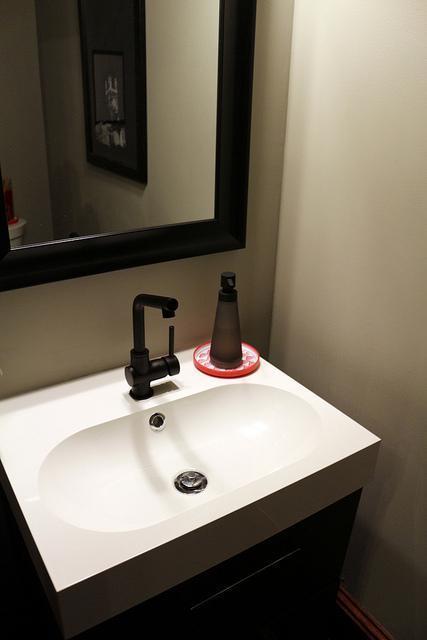How many knobs are on the faucet?
Give a very brief answer. 1. How many trains are visible?
Give a very brief answer. 0. 